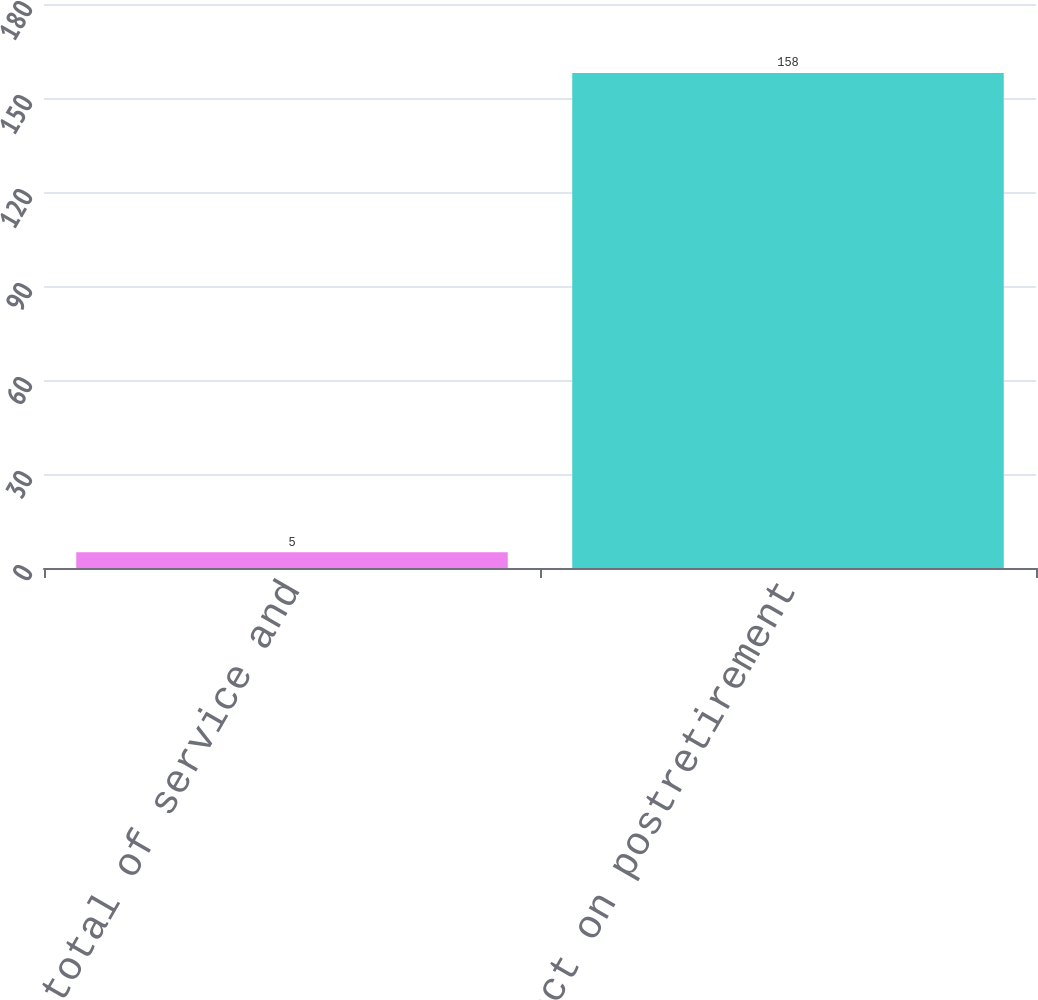Convert chart to OTSL. <chart><loc_0><loc_0><loc_500><loc_500><bar_chart><fcel>Effect on total of service and<fcel>Effect on postretirement<nl><fcel>5<fcel>158<nl></chart> 